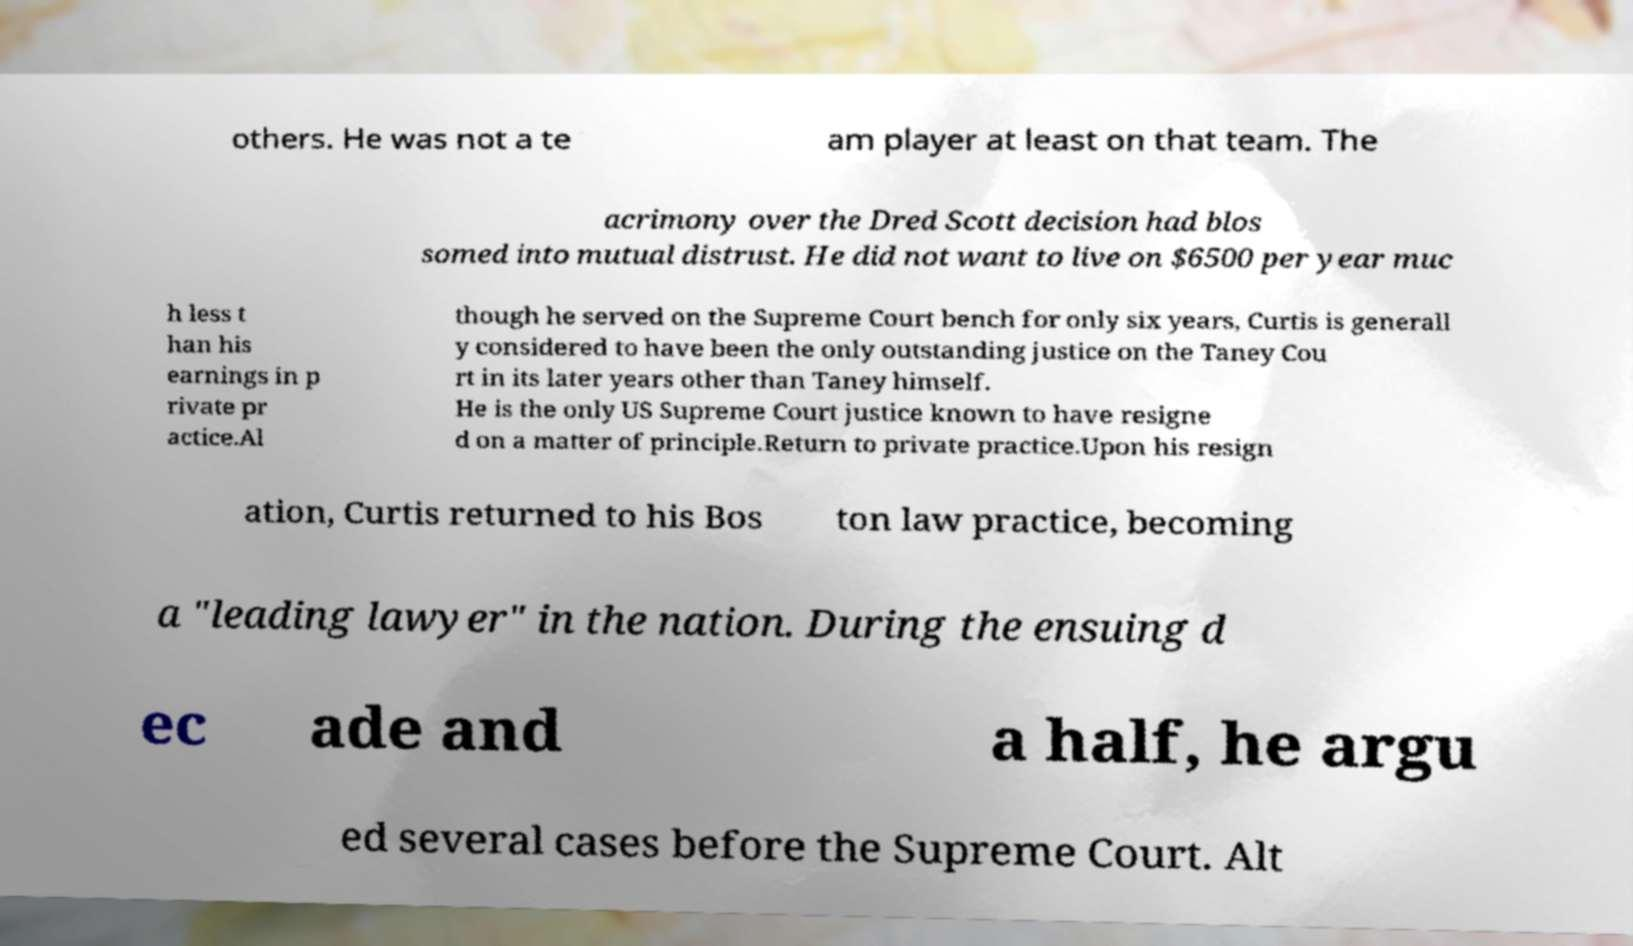Could you extract and type out the text from this image? others. He was not a te am player at least on that team. The acrimony over the Dred Scott decision had blos somed into mutual distrust. He did not want to live on $6500 per year muc h less t han his earnings in p rivate pr actice.Al though he served on the Supreme Court bench for only six years, Curtis is generall y considered to have been the only outstanding justice on the Taney Cou rt in its later years other than Taney himself. He is the only US Supreme Court justice known to have resigne d on a matter of principle.Return to private practice.Upon his resign ation, Curtis returned to his Bos ton law practice, becoming a "leading lawyer" in the nation. During the ensuing d ec ade and a half, he argu ed several cases before the Supreme Court. Alt 